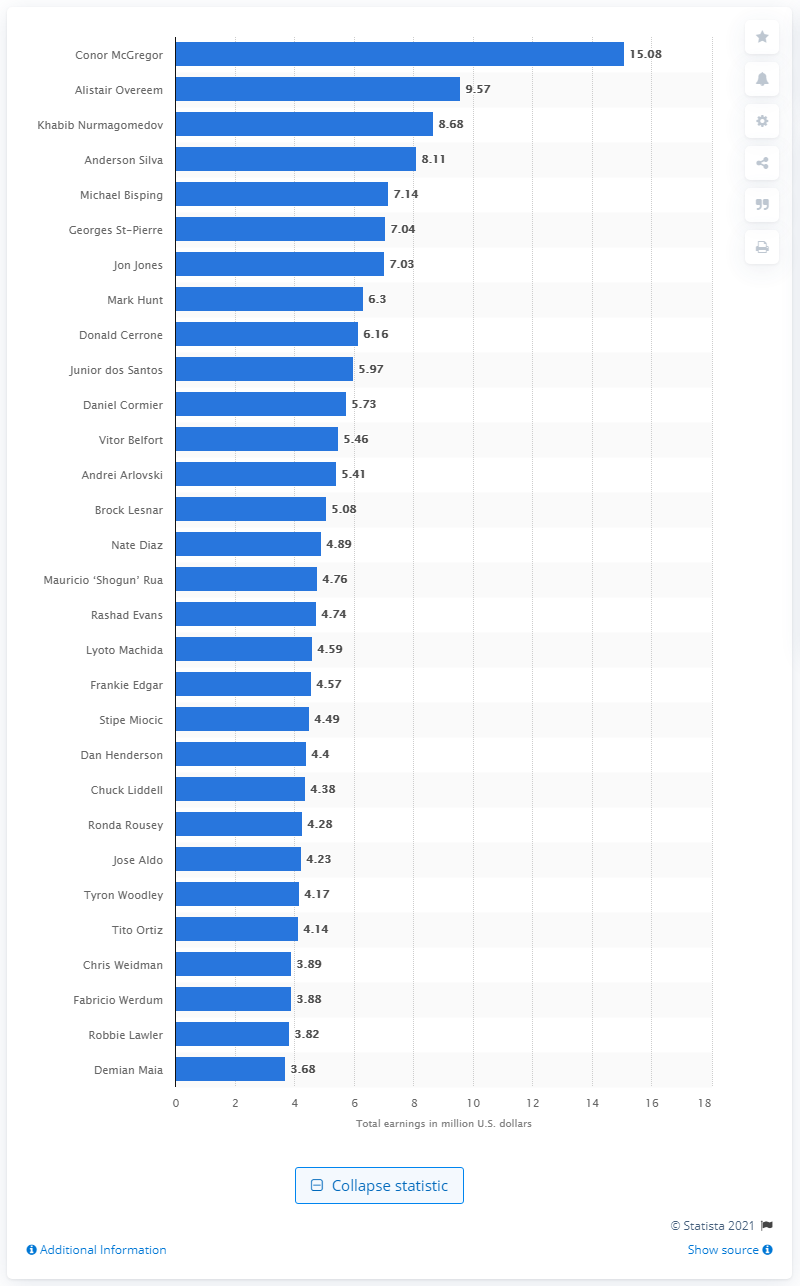Outline some significant characteristics in this image. Conor McGregor is the Ultimate Fighting Championship fighter with the highest career earnings. 